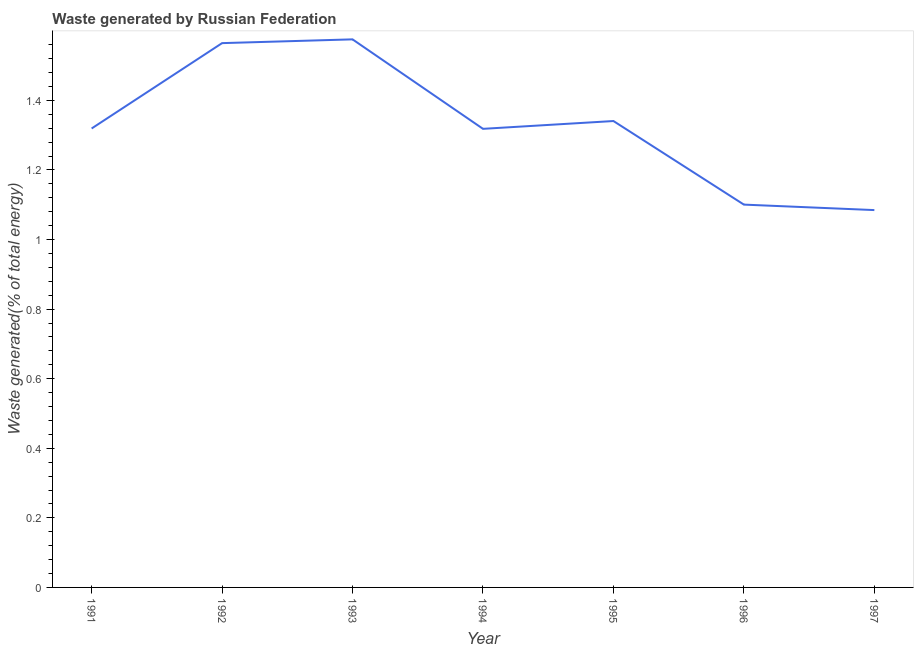What is the amount of waste generated in 1994?
Your answer should be compact. 1.32. Across all years, what is the maximum amount of waste generated?
Ensure brevity in your answer.  1.58. Across all years, what is the minimum amount of waste generated?
Offer a very short reply. 1.08. In which year was the amount of waste generated minimum?
Make the answer very short. 1997. What is the sum of the amount of waste generated?
Provide a succinct answer. 9.3. What is the difference between the amount of waste generated in 1996 and 1997?
Provide a succinct answer. 0.02. What is the average amount of waste generated per year?
Provide a succinct answer. 1.33. What is the median amount of waste generated?
Ensure brevity in your answer.  1.32. In how many years, is the amount of waste generated greater than 0.56 %?
Your answer should be very brief. 7. Do a majority of the years between 1994 and 1992 (inclusive) have amount of waste generated greater than 0.12 %?
Make the answer very short. No. What is the ratio of the amount of waste generated in 1995 to that in 1997?
Provide a short and direct response. 1.24. What is the difference between the highest and the second highest amount of waste generated?
Ensure brevity in your answer.  0.01. Is the sum of the amount of waste generated in 1996 and 1997 greater than the maximum amount of waste generated across all years?
Provide a succinct answer. Yes. What is the difference between the highest and the lowest amount of waste generated?
Provide a succinct answer. 0.49. Does the amount of waste generated monotonically increase over the years?
Offer a very short reply. No. How many lines are there?
Your response must be concise. 1. How many years are there in the graph?
Offer a terse response. 7. What is the difference between two consecutive major ticks on the Y-axis?
Offer a terse response. 0.2. Are the values on the major ticks of Y-axis written in scientific E-notation?
Make the answer very short. No. What is the title of the graph?
Your answer should be very brief. Waste generated by Russian Federation. What is the label or title of the X-axis?
Your response must be concise. Year. What is the label or title of the Y-axis?
Keep it short and to the point. Waste generated(% of total energy). What is the Waste generated(% of total energy) in 1991?
Ensure brevity in your answer.  1.32. What is the Waste generated(% of total energy) in 1992?
Offer a very short reply. 1.56. What is the Waste generated(% of total energy) of 1993?
Give a very brief answer. 1.58. What is the Waste generated(% of total energy) of 1994?
Your answer should be compact. 1.32. What is the Waste generated(% of total energy) of 1995?
Provide a succinct answer. 1.34. What is the Waste generated(% of total energy) in 1996?
Give a very brief answer. 1.1. What is the Waste generated(% of total energy) of 1997?
Your answer should be very brief. 1.08. What is the difference between the Waste generated(% of total energy) in 1991 and 1992?
Make the answer very short. -0.25. What is the difference between the Waste generated(% of total energy) in 1991 and 1993?
Offer a very short reply. -0.26. What is the difference between the Waste generated(% of total energy) in 1991 and 1994?
Keep it short and to the point. 0. What is the difference between the Waste generated(% of total energy) in 1991 and 1995?
Your response must be concise. -0.02. What is the difference between the Waste generated(% of total energy) in 1991 and 1996?
Provide a succinct answer. 0.22. What is the difference between the Waste generated(% of total energy) in 1991 and 1997?
Give a very brief answer. 0.23. What is the difference between the Waste generated(% of total energy) in 1992 and 1993?
Your answer should be very brief. -0.01. What is the difference between the Waste generated(% of total energy) in 1992 and 1994?
Your response must be concise. 0.25. What is the difference between the Waste generated(% of total energy) in 1992 and 1995?
Ensure brevity in your answer.  0.22. What is the difference between the Waste generated(% of total energy) in 1992 and 1996?
Provide a succinct answer. 0.46. What is the difference between the Waste generated(% of total energy) in 1992 and 1997?
Your answer should be very brief. 0.48. What is the difference between the Waste generated(% of total energy) in 1993 and 1994?
Make the answer very short. 0.26. What is the difference between the Waste generated(% of total energy) in 1993 and 1995?
Your answer should be compact. 0.23. What is the difference between the Waste generated(% of total energy) in 1993 and 1996?
Offer a terse response. 0.48. What is the difference between the Waste generated(% of total energy) in 1993 and 1997?
Provide a short and direct response. 0.49. What is the difference between the Waste generated(% of total energy) in 1994 and 1995?
Your answer should be compact. -0.02. What is the difference between the Waste generated(% of total energy) in 1994 and 1996?
Keep it short and to the point. 0.22. What is the difference between the Waste generated(% of total energy) in 1994 and 1997?
Your response must be concise. 0.23. What is the difference between the Waste generated(% of total energy) in 1995 and 1996?
Offer a very short reply. 0.24. What is the difference between the Waste generated(% of total energy) in 1995 and 1997?
Make the answer very short. 0.26. What is the difference between the Waste generated(% of total energy) in 1996 and 1997?
Ensure brevity in your answer.  0.02. What is the ratio of the Waste generated(% of total energy) in 1991 to that in 1992?
Provide a succinct answer. 0.84. What is the ratio of the Waste generated(% of total energy) in 1991 to that in 1993?
Your response must be concise. 0.84. What is the ratio of the Waste generated(% of total energy) in 1991 to that in 1996?
Offer a very short reply. 1.2. What is the ratio of the Waste generated(% of total energy) in 1991 to that in 1997?
Offer a very short reply. 1.22. What is the ratio of the Waste generated(% of total energy) in 1992 to that in 1994?
Ensure brevity in your answer.  1.19. What is the ratio of the Waste generated(% of total energy) in 1992 to that in 1995?
Your answer should be very brief. 1.17. What is the ratio of the Waste generated(% of total energy) in 1992 to that in 1996?
Keep it short and to the point. 1.42. What is the ratio of the Waste generated(% of total energy) in 1992 to that in 1997?
Your answer should be very brief. 1.44. What is the ratio of the Waste generated(% of total energy) in 1993 to that in 1994?
Your response must be concise. 1.2. What is the ratio of the Waste generated(% of total energy) in 1993 to that in 1995?
Provide a succinct answer. 1.18. What is the ratio of the Waste generated(% of total energy) in 1993 to that in 1996?
Offer a very short reply. 1.43. What is the ratio of the Waste generated(% of total energy) in 1993 to that in 1997?
Make the answer very short. 1.45. What is the ratio of the Waste generated(% of total energy) in 1994 to that in 1996?
Provide a short and direct response. 1.2. What is the ratio of the Waste generated(% of total energy) in 1994 to that in 1997?
Keep it short and to the point. 1.22. What is the ratio of the Waste generated(% of total energy) in 1995 to that in 1996?
Your response must be concise. 1.22. What is the ratio of the Waste generated(% of total energy) in 1995 to that in 1997?
Ensure brevity in your answer.  1.24. What is the ratio of the Waste generated(% of total energy) in 1996 to that in 1997?
Offer a very short reply. 1.01. 